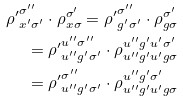Convert formula to latex. <formula><loc_0><loc_0><loc_500><loc_500>{ \rho ^ { \prime } } _ { x ^ { \prime } \sigma ^ { \prime } } ^ { \sigma ^ { \prime \prime } } \cdot \rho _ { x \sigma } ^ { \sigma ^ { \prime } } = { \rho ^ { \prime } } _ { g ^ { \prime } \sigma ^ { \prime } } ^ { \sigma ^ { \prime \prime } } \cdot \rho _ { g \sigma } ^ { \sigma ^ { \prime } } \\ = { \rho ^ { \prime } } _ { u ^ { \prime \prime } g ^ { \prime } \sigma ^ { \prime } } ^ { u ^ { \prime \prime } \sigma ^ { \prime \prime } } \cdot \rho _ { u ^ { \prime \prime } g ^ { \prime } u ^ { \prime } g \sigma } ^ { u ^ { \prime \prime } g ^ { \prime } u ^ { \prime } \sigma ^ { \prime } } \\ = { \rho ^ { \prime } } _ { u ^ { \prime \prime } g ^ { \prime } \sigma ^ { \prime } } ^ { \sigma ^ { \prime \prime } } \cdot \rho _ { u ^ { \prime \prime } g ^ { \prime } u ^ { \prime } g \sigma } ^ { u ^ { \prime \prime } g ^ { \prime } \sigma ^ { \prime } }</formula> 